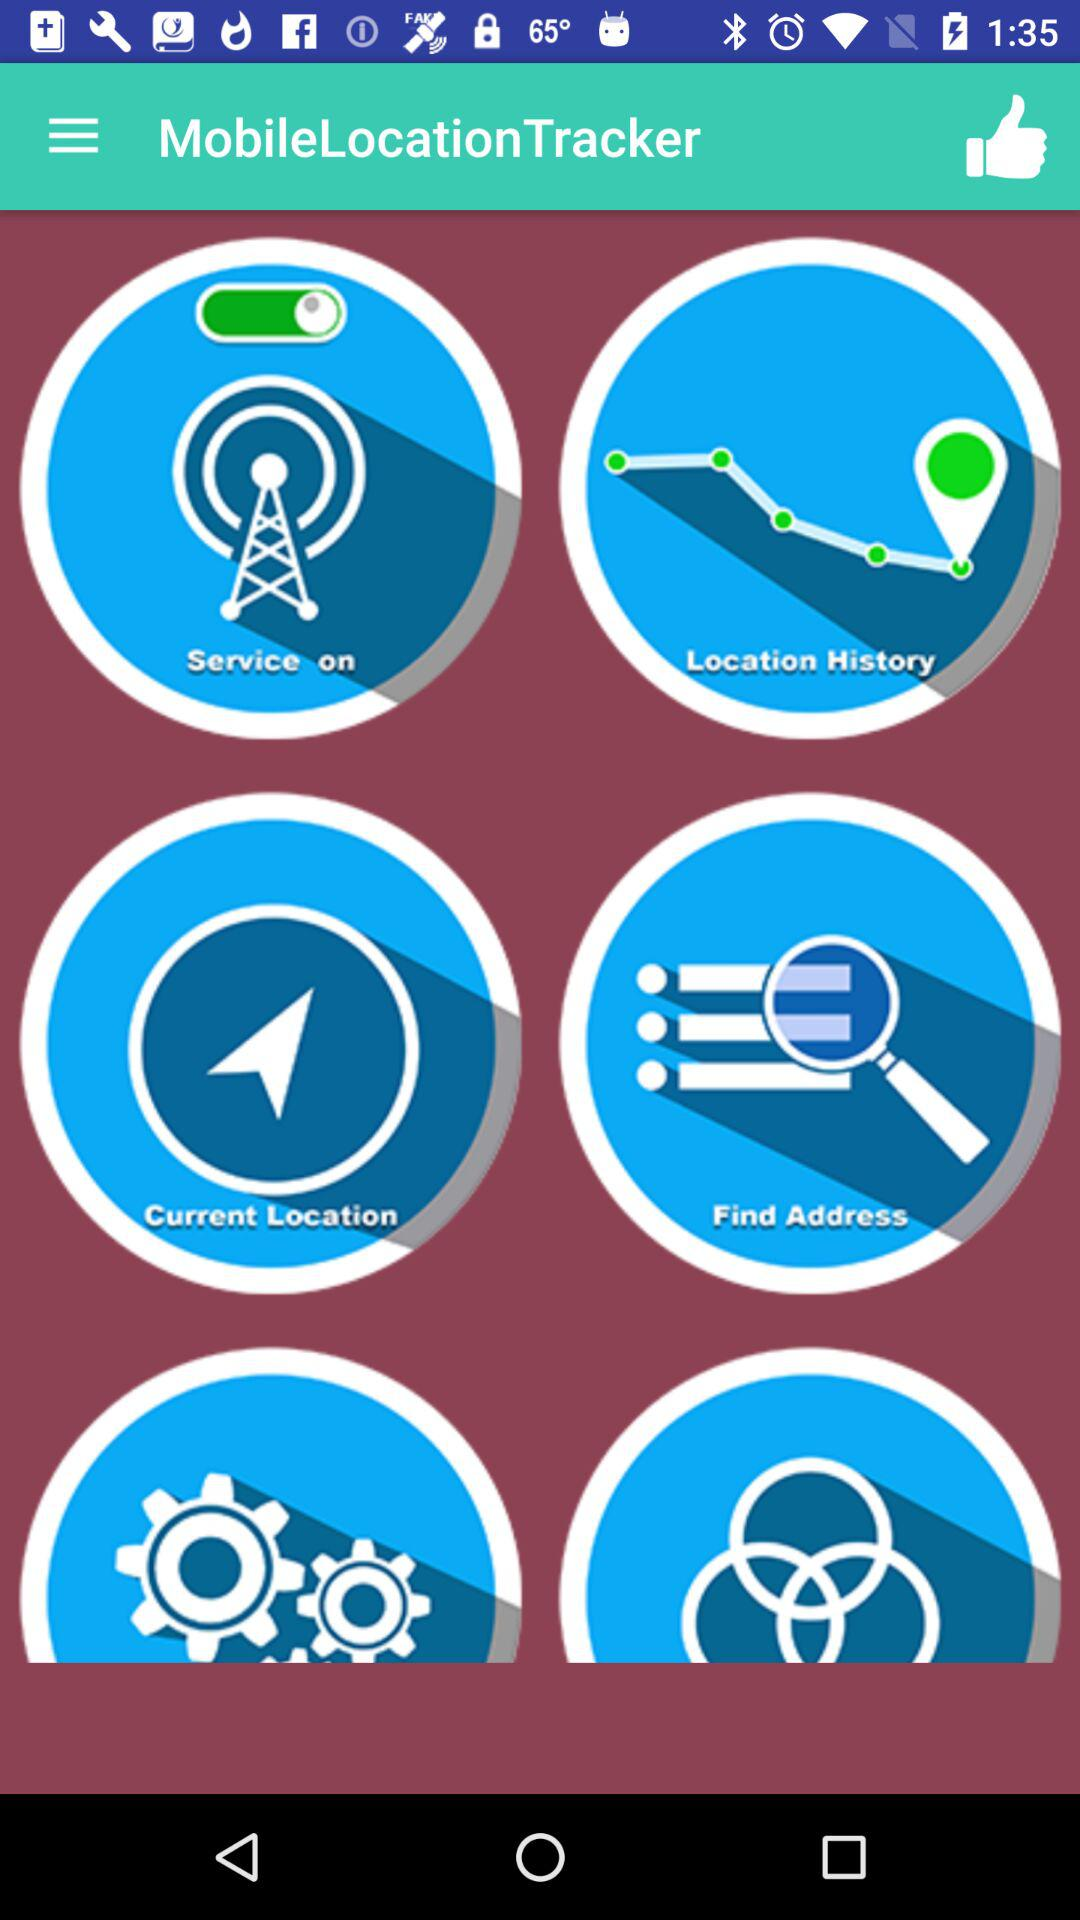What is the name of the application? The name of the application is "MobileLocationTracker". 